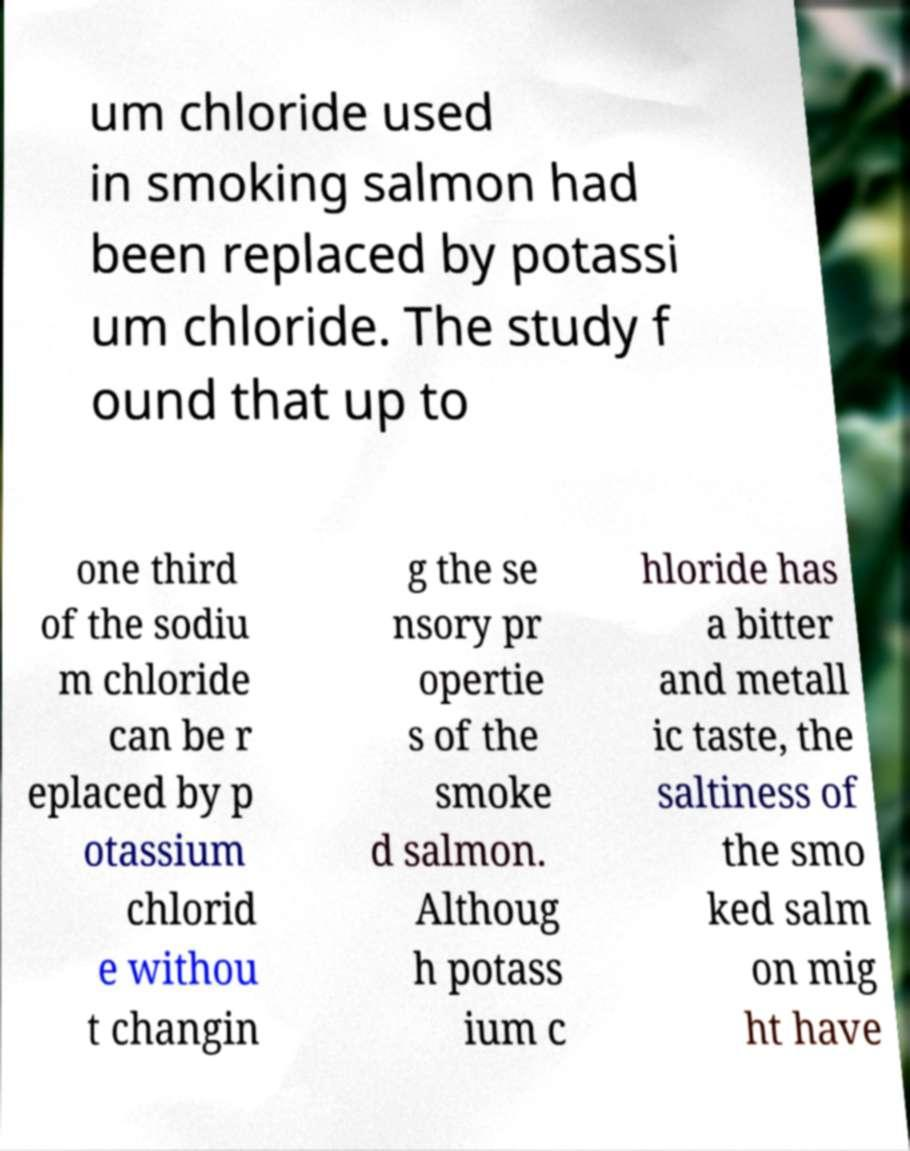There's text embedded in this image that I need extracted. Can you transcribe it verbatim? um chloride used in smoking salmon had been replaced by potassi um chloride. The study f ound that up to one third of the sodiu m chloride can be r eplaced by p otassium chlorid e withou t changin g the se nsory pr opertie s of the smoke d salmon. Althoug h potass ium c hloride has a bitter and metall ic taste, the saltiness of the smo ked salm on mig ht have 